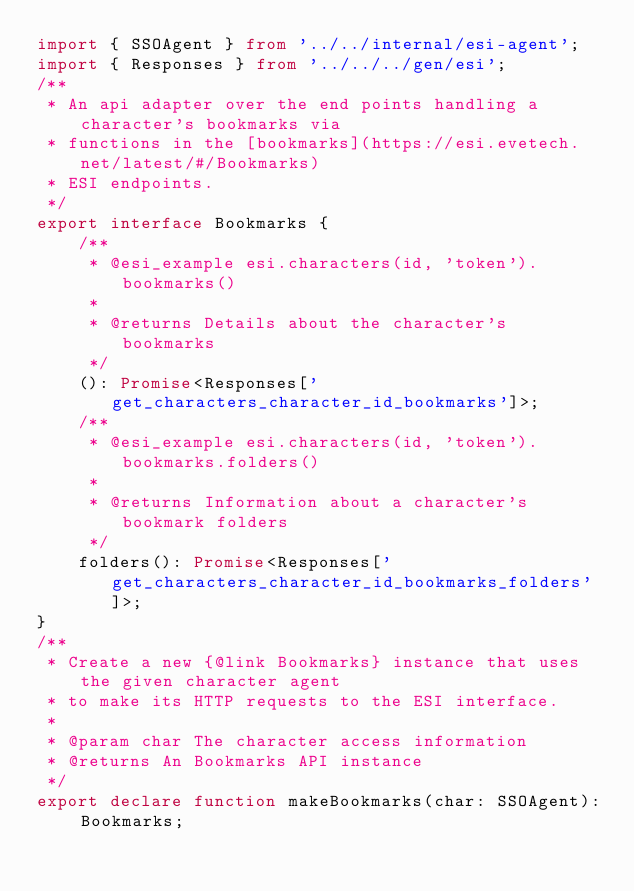Convert code to text. <code><loc_0><loc_0><loc_500><loc_500><_TypeScript_>import { SSOAgent } from '../../internal/esi-agent';
import { Responses } from '../../../gen/esi';
/**
 * An api adapter over the end points handling a character's bookmarks via
 * functions in the [bookmarks](https://esi.evetech.net/latest/#/Bookmarks)
 * ESI endpoints.
 */
export interface Bookmarks {
    /**
     * @esi_example esi.characters(id, 'token').bookmarks()
     *
     * @returns Details about the character's bookmarks
     */
    (): Promise<Responses['get_characters_character_id_bookmarks']>;
    /**
     * @esi_example esi.characters(id, 'token').bookmarks.folders()
     *
     * @returns Information about a character's bookmark folders
     */
    folders(): Promise<Responses['get_characters_character_id_bookmarks_folders']>;
}
/**
 * Create a new {@link Bookmarks} instance that uses the given character agent
 * to make its HTTP requests to the ESI interface.
 *
 * @param char The character access information
 * @returns An Bookmarks API instance
 */
export declare function makeBookmarks(char: SSOAgent): Bookmarks;
</code> 